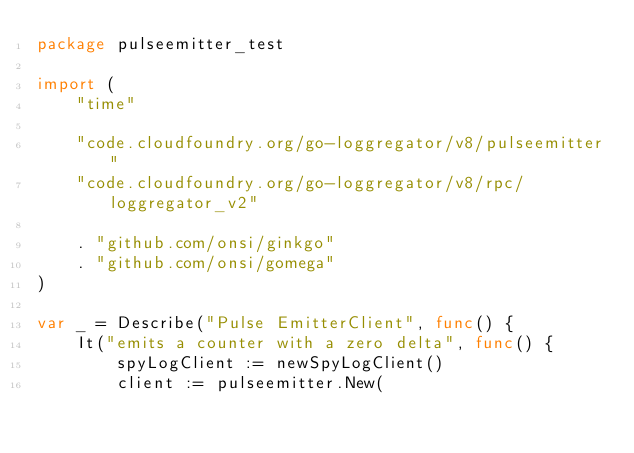Convert code to text. <code><loc_0><loc_0><loc_500><loc_500><_Go_>package pulseemitter_test

import (
	"time"

	"code.cloudfoundry.org/go-loggregator/v8/pulseemitter"
	"code.cloudfoundry.org/go-loggregator/v8/rpc/loggregator_v2"

	. "github.com/onsi/ginkgo"
	. "github.com/onsi/gomega"
)

var _ = Describe("Pulse EmitterClient", func() {
	It("emits a counter with a zero delta", func() {
		spyLogClient := newSpyLogClient()
		client := pulseemitter.New(</code> 